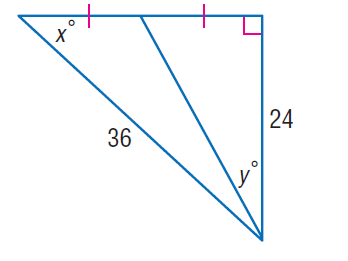Answer the mathemtical geometry problem and directly provide the correct option letter.
Question: Find x.
Choices: A: 41.8 B: 42.9 C: 67.1 D: 76.4 A 